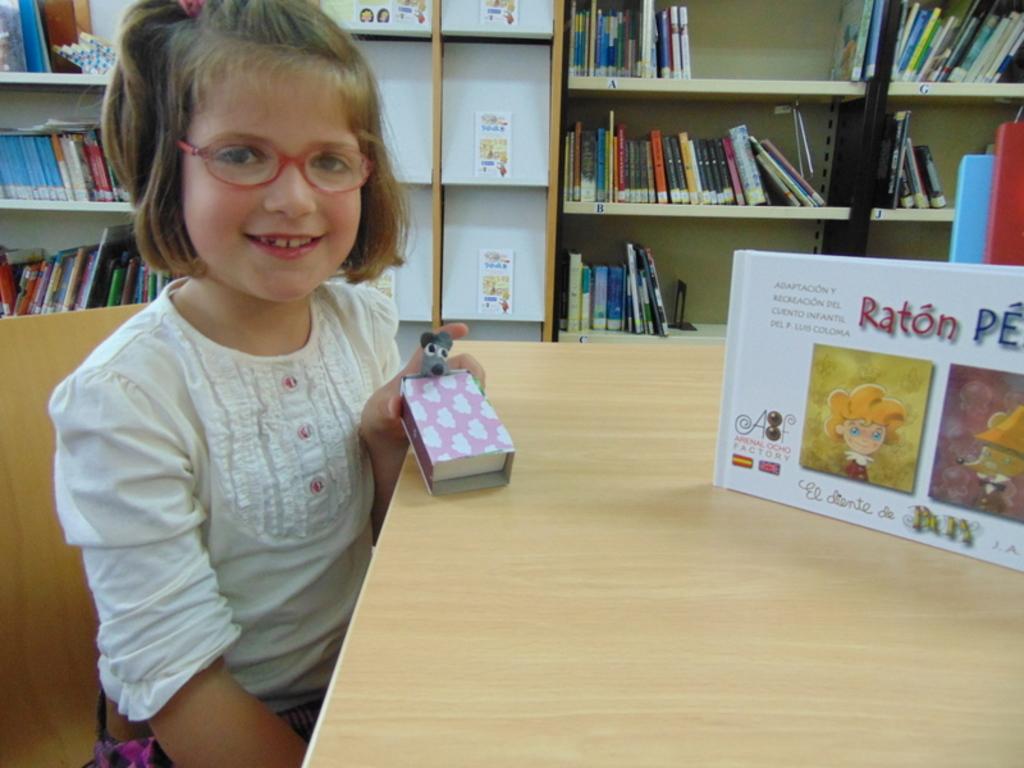What is the animal name on the book?
Provide a succinct answer. Raton. 